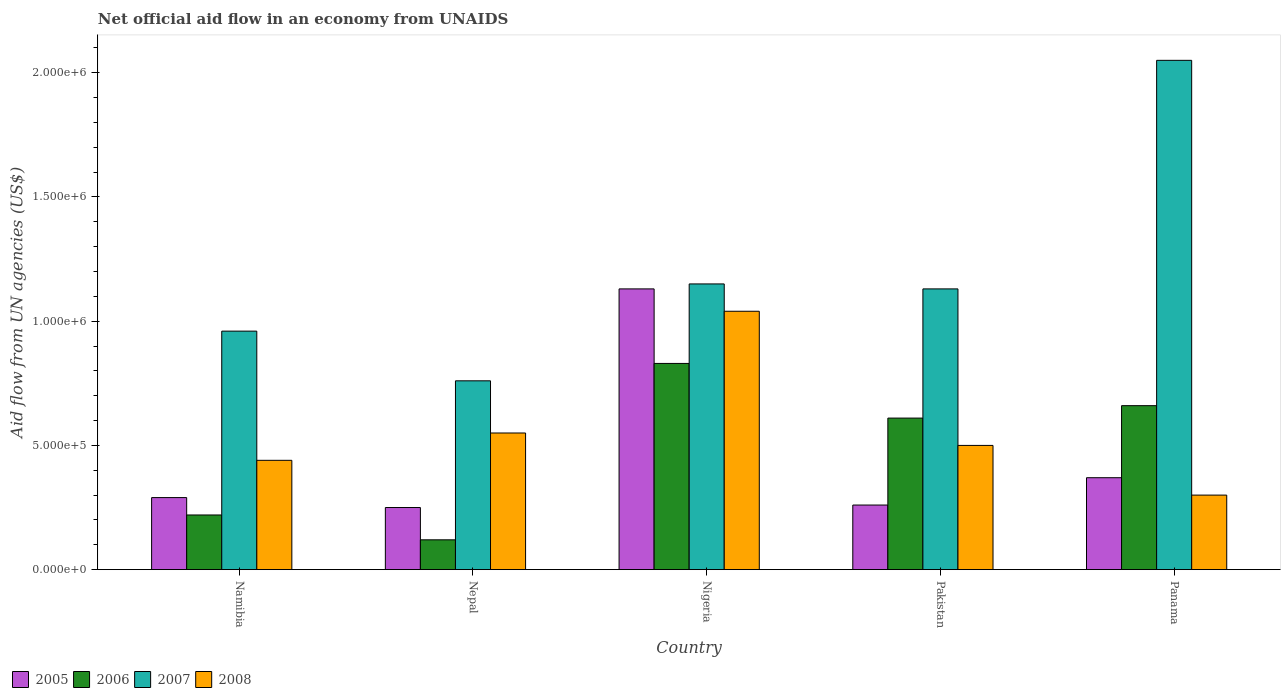How many groups of bars are there?
Make the answer very short. 5. Are the number of bars per tick equal to the number of legend labels?
Make the answer very short. Yes. How many bars are there on the 2nd tick from the left?
Provide a succinct answer. 4. How many bars are there on the 1st tick from the right?
Your answer should be compact. 4. What is the label of the 1st group of bars from the left?
Make the answer very short. Namibia. Across all countries, what is the maximum net official aid flow in 2008?
Make the answer very short. 1.04e+06. In which country was the net official aid flow in 2007 maximum?
Your answer should be compact. Panama. In which country was the net official aid flow in 2008 minimum?
Give a very brief answer. Panama. What is the total net official aid flow in 2007 in the graph?
Your response must be concise. 6.05e+06. What is the difference between the net official aid flow in 2006 in Nepal and that in Pakistan?
Provide a succinct answer. -4.90e+05. What is the difference between the net official aid flow in 2007 in Pakistan and the net official aid flow in 2008 in Namibia?
Ensure brevity in your answer.  6.90e+05. What is the average net official aid flow in 2005 per country?
Keep it short and to the point. 4.60e+05. What is the ratio of the net official aid flow in 2007 in Nigeria to that in Pakistan?
Ensure brevity in your answer.  1.02. Is the net official aid flow in 2008 in Nepal less than that in Panama?
Provide a short and direct response. No. Is the difference between the net official aid flow in 2006 in Nepal and Pakistan greater than the difference between the net official aid flow in 2005 in Nepal and Pakistan?
Give a very brief answer. No. What is the difference between the highest and the second highest net official aid flow in 2008?
Offer a terse response. 5.40e+05. What is the difference between the highest and the lowest net official aid flow in 2006?
Offer a terse response. 7.10e+05. Is it the case that in every country, the sum of the net official aid flow in 2007 and net official aid flow in 2005 is greater than the sum of net official aid flow in 2006 and net official aid flow in 2008?
Offer a very short reply. Yes. What does the 3rd bar from the left in Namibia represents?
Keep it short and to the point. 2007. What does the 4th bar from the right in Pakistan represents?
Make the answer very short. 2005. Are the values on the major ticks of Y-axis written in scientific E-notation?
Ensure brevity in your answer.  Yes. Does the graph contain any zero values?
Offer a very short reply. No. Does the graph contain grids?
Provide a short and direct response. No. How are the legend labels stacked?
Give a very brief answer. Horizontal. What is the title of the graph?
Keep it short and to the point. Net official aid flow in an economy from UNAIDS. Does "1998" appear as one of the legend labels in the graph?
Keep it short and to the point. No. What is the label or title of the X-axis?
Provide a succinct answer. Country. What is the label or title of the Y-axis?
Make the answer very short. Aid flow from UN agencies (US$). What is the Aid flow from UN agencies (US$) in 2005 in Namibia?
Offer a very short reply. 2.90e+05. What is the Aid flow from UN agencies (US$) of 2006 in Namibia?
Give a very brief answer. 2.20e+05. What is the Aid flow from UN agencies (US$) in 2007 in Namibia?
Provide a short and direct response. 9.60e+05. What is the Aid flow from UN agencies (US$) of 2006 in Nepal?
Offer a terse response. 1.20e+05. What is the Aid flow from UN agencies (US$) of 2007 in Nepal?
Offer a very short reply. 7.60e+05. What is the Aid flow from UN agencies (US$) in 2005 in Nigeria?
Your answer should be very brief. 1.13e+06. What is the Aid flow from UN agencies (US$) of 2006 in Nigeria?
Offer a terse response. 8.30e+05. What is the Aid flow from UN agencies (US$) of 2007 in Nigeria?
Ensure brevity in your answer.  1.15e+06. What is the Aid flow from UN agencies (US$) of 2008 in Nigeria?
Keep it short and to the point. 1.04e+06. What is the Aid flow from UN agencies (US$) in 2007 in Pakistan?
Offer a terse response. 1.13e+06. What is the Aid flow from UN agencies (US$) of 2005 in Panama?
Your answer should be compact. 3.70e+05. What is the Aid flow from UN agencies (US$) in 2007 in Panama?
Provide a short and direct response. 2.05e+06. Across all countries, what is the maximum Aid flow from UN agencies (US$) of 2005?
Keep it short and to the point. 1.13e+06. Across all countries, what is the maximum Aid flow from UN agencies (US$) in 2006?
Offer a very short reply. 8.30e+05. Across all countries, what is the maximum Aid flow from UN agencies (US$) of 2007?
Keep it short and to the point. 2.05e+06. Across all countries, what is the maximum Aid flow from UN agencies (US$) of 2008?
Provide a short and direct response. 1.04e+06. Across all countries, what is the minimum Aid flow from UN agencies (US$) in 2006?
Ensure brevity in your answer.  1.20e+05. Across all countries, what is the minimum Aid flow from UN agencies (US$) of 2007?
Offer a terse response. 7.60e+05. Across all countries, what is the minimum Aid flow from UN agencies (US$) of 2008?
Ensure brevity in your answer.  3.00e+05. What is the total Aid flow from UN agencies (US$) of 2005 in the graph?
Keep it short and to the point. 2.30e+06. What is the total Aid flow from UN agencies (US$) in 2006 in the graph?
Ensure brevity in your answer.  2.44e+06. What is the total Aid flow from UN agencies (US$) of 2007 in the graph?
Ensure brevity in your answer.  6.05e+06. What is the total Aid flow from UN agencies (US$) of 2008 in the graph?
Give a very brief answer. 2.83e+06. What is the difference between the Aid flow from UN agencies (US$) of 2005 in Namibia and that in Nepal?
Provide a short and direct response. 4.00e+04. What is the difference between the Aid flow from UN agencies (US$) of 2005 in Namibia and that in Nigeria?
Your response must be concise. -8.40e+05. What is the difference between the Aid flow from UN agencies (US$) of 2006 in Namibia and that in Nigeria?
Ensure brevity in your answer.  -6.10e+05. What is the difference between the Aid flow from UN agencies (US$) of 2008 in Namibia and that in Nigeria?
Ensure brevity in your answer.  -6.00e+05. What is the difference between the Aid flow from UN agencies (US$) in 2006 in Namibia and that in Pakistan?
Offer a very short reply. -3.90e+05. What is the difference between the Aid flow from UN agencies (US$) of 2008 in Namibia and that in Pakistan?
Ensure brevity in your answer.  -6.00e+04. What is the difference between the Aid flow from UN agencies (US$) in 2006 in Namibia and that in Panama?
Your response must be concise. -4.40e+05. What is the difference between the Aid flow from UN agencies (US$) of 2007 in Namibia and that in Panama?
Provide a short and direct response. -1.09e+06. What is the difference between the Aid flow from UN agencies (US$) of 2008 in Namibia and that in Panama?
Offer a very short reply. 1.40e+05. What is the difference between the Aid flow from UN agencies (US$) in 2005 in Nepal and that in Nigeria?
Your answer should be very brief. -8.80e+05. What is the difference between the Aid flow from UN agencies (US$) of 2006 in Nepal and that in Nigeria?
Give a very brief answer. -7.10e+05. What is the difference between the Aid flow from UN agencies (US$) of 2007 in Nepal and that in Nigeria?
Offer a very short reply. -3.90e+05. What is the difference between the Aid flow from UN agencies (US$) in 2008 in Nepal and that in Nigeria?
Offer a very short reply. -4.90e+05. What is the difference between the Aid flow from UN agencies (US$) in 2006 in Nepal and that in Pakistan?
Provide a short and direct response. -4.90e+05. What is the difference between the Aid flow from UN agencies (US$) of 2007 in Nepal and that in Pakistan?
Offer a terse response. -3.70e+05. What is the difference between the Aid flow from UN agencies (US$) of 2005 in Nepal and that in Panama?
Give a very brief answer. -1.20e+05. What is the difference between the Aid flow from UN agencies (US$) in 2006 in Nepal and that in Panama?
Provide a short and direct response. -5.40e+05. What is the difference between the Aid flow from UN agencies (US$) in 2007 in Nepal and that in Panama?
Ensure brevity in your answer.  -1.29e+06. What is the difference between the Aid flow from UN agencies (US$) in 2008 in Nepal and that in Panama?
Give a very brief answer. 2.50e+05. What is the difference between the Aid flow from UN agencies (US$) in 2005 in Nigeria and that in Pakistan?
Make the answer very short. 8.70e+05. What is the difference between the Aid flow from UN agencies (US$) of 2006 in Nigeria and that in Pakistan?
Offer a very short reply. 2.20e+05. What is the difference between the Aid flow from UN agencies (US$) in 2007 in Nigeria and that in Pakistan?
Give a very brief answer. 2.00e+04. What is the difference between the Aid flow from UN agencies (US$) of 2008 in Nigeria and that in Pakistan?
Your answer should be compact. 5.40e+05. What is the difference between the Aid flow from UN agencies (US$) in 2005 in Nigeria and that in Panama?
Your response must be concise. 7.60e+05. What is the difference between the Aid flow from UN agencies (US$) of 2006 in Nigeria and that in Panama?
Your answer should be very brief. 1.70e+05. What is the difference between the Aid flow from UN agencies (US$) in 2007 in Nigeria and that in Panama?
Ensure brevity in your answer.  -9.00e+05. What is the difference between the Aid flow from UN agencies (US$) of 2008 in Nigeria and that in Panama?
Make the answer very short. 7.40e+05. What is the difference between the Aid flow from UN agencies (US$) in 2005 in Pakistan and that in Panama?
Keep it short and to the point. -1.10e+05. What is the difference between the Aid flow from UN agencies (US$) in 2007 in Pakistan and that in Panama?
Your response must be concise. -9.20e+05. What is the difference between the Aid flow from UN agencies (US$) in 2008 in Pakistan and that in Panama?
Your answer should be compact. 2.00e+05. What is the difference between the Aid flow from UN agencies (US$) of 2005 in Namibia and the Aid flow from UN agencies (US$) of 2006 in Nepal?
Give a very brief answer. 1.70e+05. What is the difference between the Aid flow from UN agencies (US$) in 2005 in Namibia and the Aid flow from UN agencies (US$) in 2007 in Nepal?
Offer a very short reply. -4.70e+05. What is the difference between the Aid flow from UN agencies (US$) of 2006 in Namibia and the Aid flow from UN agencies (US$) of 2007 in Nepal?
Offer a terse response. -5.40e+05. What is the difference between the Aid flow from UN agencies (US$) in 2006 in Namibia and the Aid flow from UN agencies (US$) in 2008 in Nepal?
Your answer should be compact. -3.30e+05. What is the difference between the Aid flow from UN agencies (US$) in 2007 in Namibia and the Aid flow from UN agencies (US$) in 2008 in Nepal?
Offer a terse response. 4.10e+05. What is the difference between the Aid flow from UN agencies (US$) of 2005 in Namibia and the Aid flow from UN agencies (US$) of 2006 in Nigeria?
Keep it short and to the point. -5.40e+05. What is the difference between the Aid flow from UN agencies (US$) in 2005 in Namibia and the Aid flow from UN agencies (US$) in 2007 in Nigeria?
Keep it short and to the point. -8.60e+05. What is the difference between the Aid flow from UN agencies (US$) of 2005 in Namibia and the Aid flow from UN agencies (US$) of 2008 in Nigeria?
Your response must be concise. -7.50e+05. What is the difference between the Aid flow from UN agencies (US$) in 2006 in Namibia and the Aid flow from UN agencies (US$) in 2007 in Nigeria?
Ensure brevity in your answer.  -9.30e+05. What is the difference between the Aid flow from UN agencies (US$) of 2006 in Namibia and the Aid flow from UN agencies (US$) of 2008 in Nigeria?
Provide a short and direct response. -8.20e+05. What is the difference between the Aid flow from UN agencies (US$) in 2005 in Namibia and the Aid flow from UN agencies (US$) in 2006 in Pakistan?
Ensure brevity in your answer.  -3.20e+05. What is the difference between the Aid flow from UN agencies (US$) of 2005 in Namibia and the Aid flow from UN agencies (US$) of 2007 in Pakistan?
Give a very brief answer. -8.40e+05. What is the difference between the Aid flow from UN agencies (US$) in 2005 in Namibia and the Aid flow from UN agencies (US$) in 2008 in Pakistan?
Make the answer very short. -2.10e+05. What is the difference between the Aid flow from UN agencies (US$) of 2006 in Namibia and the Aid flow from UN agencies (US$) of 2007 in Pakistan?
Provide a succinct answer. -9.10e+05. What is the difference between the Aid flow from UN agencies (US$) in 2006 in Namibia and the Aid flow from UN agencies (US$) in 2008 in Pakistan?
Your answer should be compact. -2.80e+05. What is the difference between the Aid flow from UN agencies (US$) in 2007 in Namibia and the Aid flow from UN agencies (US$) in 2008 in Pakistan?
Keep it short and to the point. 4.60e+05. What is the difference between the Aid flow from UN agencies (US$) in 2005 in Namibia and the Aid flow from UN agencies (US$) in 2006 in Panama?
Ensure brevity in your answer.  -3.70e+05. What is the difference between the Aid flow from UN agencies (US$) in 2005 in Namibia and the Aid flow from UN agencies (US$) in 2007 in Panama?
Give a very brief answer. -1.76e+06. What is the difference between the Aid flow from UN agencies (US$) of 2005 in Namibia and the Aid flow from UN agencies (US$) of 2008 in Panama?
Keep it short and to the point. -10000. What is the difference between the Aid flow from UN agencies (US$) in 2006 in Namibia and the Aid flow from UN agencies (US$) in 2007 in Panama?
Make the answer very short. -1.83e+06. What is the difference between the Aid flow from UN agencies (US$) of 2007 in Namibia and the Aid flow from UN agencies (US$) of 2008 in Panama?
Offer a terse response. 6.60e+05. What is the difference between the Aid flow from UN agencies (US$) of 2005 in Nepal and the Aid flow from UN agencies (US$) of 2006 in Nigeria?
Ensure brevity in your answer.  -5.80e+05. What is the difference between the Aid flow from UN agencies (US$) in 2005 in Nepal and the Aid flow from UN agencies (US$) in 2007 in Nigeria?
Make the answer very short. -9.00e+05. What is the difference between the Aid flow from UN agencies (US$) in 2005 in Nepal and the Aid flow from UN agencies (US$) in 2008 in Nigeria?
Keep it short and to the point. -7.90e+05. What is the difference between the Aid flow from UN agencies (US$) in 2006 in Nepal and the Aid flow from UN agencies (US$) in 2007 in Nigeria?
Make the answer very short. -1.03e+06. What is the difference between the Aid flow from UN agencies (US$) in 2006 in Nepal and the Aid flow from UN agencies (US$) in 2008 in Nigeria?
Your answer should be compact. -9.20e+05. What is the difference between the Aid flow from UN agencies (US$) of 2007 in Nepal and the Aid flow from UN agencies (US$) of 2008 in Nigeria?
Your response must be concise. -2.80e+05. What is the difference between the Aid flow from UN agencies (US$) of 2005 in Nepal and the Aid flow from UN agencies (US$) of 2006 in Pakistan?
Offer a terse response. -3.60e+05. What is the difference between the Aid flow from UN agencies (US$) of 2005 in Nepal and the Aid flow from UN agencies (US$) of 2007 in Pakistan?
Give a very brief answer. -8.80e+05. What is the difference between the Aid flow from UN agencies (US$) in 2006 in Nepal and the Aid flow from UN agencies (US$) in 2007 in Pakistan?
Your answer should be compact. -1.01e+06. What is the difference between the Aid flow from UN agencies (US$) of 2006 in Nepal and the Aid flow from UN agencies (US$) of 2008 in Pakistan?
Provide a succinct answer. -3.80e+05. What is the difference between the Aid flow from UN agencies (US$) in 2007 in Nepal and the Aid flow from UN agencies (US$) in 2008 in Pakistan?
Keep it short and to the point. 2.60e+05. What is the difference between the Aid flow from UN agencies (US$) of 2005 in Nepal and the Aid flow from UN agencies (US$) of 2006 in Panama?
Provide a succinct answer. -4.10e+05. What is the difference between the Aid flow from UN agencies (US$) in 2005 in Nepal and the Aid flow from UN agencies (US$) in 2007 in Panama?
Ensure brevity in your answer.  -1.80e+06. What is the difference between the Aid flow from UN agencies (US$) of 2005 in Nepal and the Aid flow from UN agencies (US$) of 2008 in Panama?
Keep it short and to the point. -5.00e+04. What is the difference between the Aid flow from UN agencies (US$) of 2006 in Nepal and the Aid flow from UN agencies (US$) of 2007 in Panama?
Provide a short and direct response. -1.93e+06. What is the difference between the Aid flow from UN agencies (US$) of 2005 in Nigeria and the Aid flow from UN agencies (US$) of 2006 in Pakistan?
Keep it short and to the point. 5.20e+05. What is the difference between the Aid flow from UN agencies (US$) of 2005 in Nigeria and the Aid flow from UN agencies (US$) of 2007 in Pakistan?
Your answer should be compact. 0. What is the difference between the Aid flow from UN agencies (US$) of 2005 in Nigeria and the Aid flow from UN agencies (US$) of 2008 in Pakistan?
Keep it short and to the point. 6.30e+05. What is the difference between the Aid flow from UN agencies (US$) in 2006 in Nigeria and the Aid flow from UN agencies (US$) in 2007 in Pakistan?
Offer a terse response. -3.00e+05. What is the difference between the Aid flow from UN agencies (US$) of 2006 in Nigeria and the Aid flow from UN agencies (US$) of 2008 in Pakistan?
Offer a terse response. 3.30e+05. What is the difference between the Aid flow from UN agencies (US$) in 2007 in Nigeria and the Aid flow from UN agencies (US$) in 2008 in Pakistan?
Your answer should be very brief. 6.50e+05. What is the difference between the Aid flow from UN agencies (US$) of 2005 in Nigeria and the Aid flow from UN agencies (US$) of 2007 in Panama?
Provide a short and direct response. -9.20e+05. What is the difference between the Aid flow from UN agencies (US$) of 2005 in Nigeria and the Aid flow from UN agencies (US$) of 2008 in Panama?
Keep it short and to the point. 8.30e+05. What is the difference between the Aid flow from UN agencies (US$) of 2006 in Nigeria and the Aid flow from UN agencies (US$) of 2007 in Panama?
Provide a succinct answer. -1.22e+06. What is the difference between the Aid flow from UN agencies (US$) of 2006 in Nigeria and the Aid flow from UN agencies (US$) of 2008 in Panama?
Your answer should be compact. 5.30e+05. What is the difference between the Aid flow from UN agencies (US$) in 2007 in Nigeria and the Aid flow from UN agencies (US$) in 2008 in Panama?
Ensure brevity in your answer.  8.50e+05. What is the difference between the Aid flow from UN agencies (US$) in 2005 in Pakistan and the Aid flow from UN agencies (US$) in 2006 in Panama?
Give a very brief answer. -4.00e+05. What is the difference between the Aid flow from UN agencies (US$) of 2005 in Pakistan and the Aid flow from UN agencies (US$) of 2007 in Panama?
Keep it short and to the point. -1.79e+06. What is the difference between the Aid flow from UN agencies (US$) in 2006 in Pakistan and the Aid flow from UN agencies (US$) in 2007 in Panama?
Give a very brief answer. -1.44e+06. What is the difference between the Aid flow from UN agencies (US$) in 2006 in Pakistan and the Aid flow from UN agencies (US$) in 2008 in Panama?
Provide a succinct answer. 3.10e+05. What is the difference between the Aid flow from UN agencies (US$) of 2007 in Pakistan and the Aid flow from UN agencies (US$) of 2008 in Panama?
Provide a short and direct response. 8.30e+05. What is the average Aid flow from UN agencies (US$) in 2006 per country?
Provide a short and direct response. 4.88e+05. What is the average Aid flow from UN agencies (US$) of 2007 per country?
Provide a succinct answer. 1.21e+06. What is the average Aid flow from UN agencies (US$) in 2008 per country?
Make the answer very short. 5.66e+05. What is the difference between the Aid flow from UN agencies (US$) of 2005 and Aid flow from UN agencies (US$) of 2006 in Namibia?
Keep it short and to the point. 7.00e+04. What is the difference between the Aid flow from UN agencies (US$) of 2005 and Aid flow from UN agencies (US$) of 2007 in Namibia?
Give a very brief answer. -6.70e+05. What is the difference between the Aid flow from UN agencies (US$) in 2006 and Aid flow from UN agencies (US$) in 2007 in Namibia?
Ensure brevity in your answer.  -7.40e+05. What is the difference between the Aid flow from UN agencies (US$) in 2007 and Aid flow from UN agencies (US$) in 2008 in Namibia?
Give a very brief answer. 5.20e+05. What is the difference between the Aid flow from UN agencies (US$) of 2005 and Aid flow from UN agencies (US$) of 2006 in Nepal?
Your response must be concise. 1.30e+05. What is the difference between the Aid flow from UN agencies (US$) of 2005 and Aid flow from UN agencies (US$) of 2007 in Nepal?
Your answer should be compact. -5.10e+05. What is the difference between the Aid flow from UN agencies (US$) in 2005 and Aid flow from UN agencies (US$) in 2008 in Nepal?
Keep it short and to the point. -3.00e+05. What is the difference between the Aid flow from UN agencies (US$) of 2006 and Aid flow from UN agencies (US$) of 2007 in Nepal?
Make the answer very short. -6.40e+05. What is the difference between the Aid flow from UN agencies (US$) in 2006 and Aid flow from UN agencies (US$) in 2008 in Nepal?
Your response must be concise. -4.30e+05. What is the difference between the Aid flow from UN agencies (US$) of 2006 and Aid flow from UN agencies (US$) of 2007 in Nigeria?
Offer a very short reply. -3.20e+05. What is the difference between the Aid flow from UN agencies (US$) in 2006 and Aid flow from UN agencies (US$) in 2008 in Nigeria?
Provide a succinct answer. -2.10e+05. What is the difference between the Aid flow from UN agencies (US$) in 2007 and Aid flow from UN agencies (US$) in 2008 in Nigeria?
Offer a terse response. 1.10e+05. What is the difference between the Aid flow from UN agencies (US$) in 2005 and Aid flow from UN agencies (US$) in 2006 in Pakistan?
Provide a succinct answer. -3.50e+05. What is the difference between the Aid flow from UN agencies (US$) in 2005 and Aid flow from UN agencies (US$) in 2007 in Pakistan?
Keep it short and to the point. -8.70e+05. What is the difference between the Aid flow from UN agencies (US$) of 2006 and Aid flow from UN agencies (US$) of 2007 in Pakistan?
Provide a succinct answer. -5.20e+05. What is the difference between the Aid flow from UN agencies (US$) of 2007 and Aid flow from UN agencies (US$) of 2008 in Pakistan?
Provide a short and direct response. 6.30e+05. What is the difference between the Aid flow from UN agencies (US$) of 2005 and Aid flow from UN agencies (US$) of 2007 in Panama?
Make the answer very short. -1.68e+06. What is the difference between the Aid flow from UN agencies (US$) of 2006 and Aid flow from UN agencies (US$) of 2007 in Panama?
Ensure brevity in your answer.  -1.39e+06. What is the difference between the Aid flow from UN agencies (US$) in 2006 and Aid flow from UN agencies (US$) in 2008 in Panama?
Give a very brief answer. 3.60e+05. What is the difference between the Aid flow from UN agencies (US$) of 2007 and Aid flow from UN agencies (US$) of 2008 in Panama?
Keep it short and to the point. 1.75e+06. What is the ratio of the Aid flow from UN agencies (US$) of 2005 in Namibia to that in Nepal?
Offer a terse response. 1.16. What is the ratio of the Aid flow from UN agencies (US$) in 2006 in Namibia to that in Nepal?
Offer a very short reply. 1.83. What is the ratio of the Aid flow from UN agencies (US$) in 2007 in Namibia to that in Nepal?
Offer a terse response. 1.26. What is the ratio of the Aid flow from UN agencies (US$) of 2008 in Namibia to that in Nepal?
Give a very brief answer. 0.8. What is the ratio of the Aid flow from UN agencies (US$) of 2005 in Namibia to that in Nigeria?
Ensure brevity in your answer.  0.26. What is the ratio of the Aid flow from UN agencies (US$) of 2006 in Namibia to that in Nigeria?
Give a very brief answer. 0.27. What is the ratio of the Aid flow from UN agencies (US$) in 2007 in Namibia to that in Nigeria?
Your answer should be very brief. 0.83. What is the ratio of the Aid flow from UN agencies (US$) in 2008 in Namibia to that in Nigeria?
Give a very brief answer. 0.42. What is the ratio of the Aid flow from UN agencies (US$) in 2005 in Namibia to that in Pakistan?
Your answer should be compact. 1.12. What is the ratio of the Aid flow from UN agencies (US$) in 2006 in Namibia to that in Pakistan?
Give a very brief answer. 0.36. What is the ratio of the Aid flow from UN agencies (US$) in 2007 in Namibia to that in Pakistan?
Your answer should be very brief. 0.85. What is the ratio of the Aid flow from UN agencies (US$) in 2008 in Namibia to that in Pakistan?
Offer a very short reply. 0.88. What is the ratio of the Aid flow from UN agencies (US$) of 2005 in Namibia to that in Panama?
Keep it short and to the point. 0.78. What is the ratio of the Aid flow from UN agencies (US$) in 2006 in Namibia to that in Panama?
Your answer should be very brief. 0.33. What is the ratio of the Aid flow from UN agencies (US$) in 2007 in Namibia to that in Panama?
Offer a very short reply. 0.47. What is the ratio of the Aid flow from UN agencies (US$) in 2008 in Namibia to that in Panama?
Offer a very short reply. 1.47. What is the ratio of the Aid flow from UN agencies (US$) in 2005 in Nepal to that in Nigeria?
Give a very brief answer. 0.22. What is the ratio of the Aid flow from UN agencies (US$) in 2006 in Nepal to that in Nigeria?
Provide a short and direct response. 0.14. What is the ratio of the Aid flow from UN agencies (US$) of 2007 in Nepal to that in Nigeria?
Your answer should be compact. 0.66. What is the ratio of the Aid flow from UN agencies (US$) of 2008 in Nepal to that in Nigeria?
Offer a terse response. 0.53. What is the ratio of the Aid flow from UN agencies (US$) in 2005 in Nepal to that in Pakistan?
Offer a very short reply. 0.96. What is the ratio of the Aid flow from UN agencies (US$) in 2006 in Nepal to that in Pakistan?
Provide a succinct answer. 0.2. What is the ratio of the Aid flow from UN agencies (US$) in 2007 in Nepal to that in Pakistan?
Keep it short and to the point. 0.67. What is the ratio of the Aid flow from UN agencies (US$) of 2008 in Nepal to that in Pakistan?
Your answer should be compact. 1.1. What is the ratio of the Aid flow from UN agencies (US$) in 2005 in Nepal to that in Panama?
Provide a short and direct response. 0.68. What is the ratio of the Aid flow from UN agencies (US$) of 2006 in Nepal to that in Panama?
Offer a very short reply. 0.18. What is the ratio of the Aid flow from UN agencies (US$) of 2007 in Nepal to that in Panama?
Offer a terse response. 0.37. What is the ratio of the Aid flow from UN agencies (US$) in 2008 in Nepal to that in Panama?
Your response must be concise. 1.83. What is the ratio of the Aid flow from UN agencies (US$) of 2005 in Nigeria to that in Pakistan?
Ensure brevity in your answer.  4.35. What is the ratio of the Aid flow from UN agencies (US$) in 2006 in Nigeria to that in Pakistan?
Give a very brief answer. 1.36. What is the ratio of the Aid flow from UN agencies (US$) of 2007 in Nigeria to that in Pakistan?
Offer a very short reply. 1.02. What is the ratio of the Aid flow from UN agencies (US$) of 2008 in Nigeria to that in Pakistan?
Provide a short and direct response. 2.08. What is the ratio of the Aid flow from UN agencies (US$) of 2005 in Nigeria to that in Panama?
Offer a terse response. 3.05. What is the ratio of the Aid flow from UN agencies (US$) of 2006 in Nigeria to that in Panama?
Provide a succinct answer. 1.26. What is the ratio of the Aid flow from UN agencies (US$) in 2007 in Nigeria to that in Panama?
Your answer should be compact. 0.56. What is the ratio of the Aid flow from UN agencies (US$) of 2008 in Nigeria to that in Panama?
Make the answer very short. 3.47. What is the ratio of the Aid flow from UN agencies (US$) of 2005 in Pakistan to that in Panama?
Your answer should be compact. 0.7. What is the ratio of the Aid flow from UN agencies (US$) in 2006 in Pakistan to that in Panama?
Your answer should be compact. 0.92. What is the ratio of the Aid flow from UN agencies (US$) in 2007 in Pakistan to that in Panama?
Give a very brief answer. 0.55. What is the difference between the highest and the second highest Aid flow from UN agencies (US$) in 2005?
Provide a short and direct response. 7.60e+05. What is the difference between the highest and the second highest Aid flow from UN agencies (US$) in 2006?
Your response must be concise. 1.70e+05. What is the difference between the highest and the second highest Aid flow from UN agencies (US$) of 2007?
Give a very brief answer. 9.00e+05. What is the difference between the highest and the second highest Aid flow from UN agencies (US$) of 2008?
Keep it short and to the point. 4.90e+05. What is the difference between the highest and the lowest Aid flow from UN agencies (US$) of 2005?
Make the answer very short. 8.80e+05. What is the difference between the highest and the lowest Aid flow from UN agencies (US$) of 2006?
Make the answer very short. 7.10e+05. What is the difference between the highest and the lowest Aid flow from UN agencies (US$) of 2007?
Offer a terse response. 1.29e+06. What is the difference between the highest and the lowest Aid flow from UN agencies (US$) of 2008?
Your answer should be compact. 7.40e+05. 